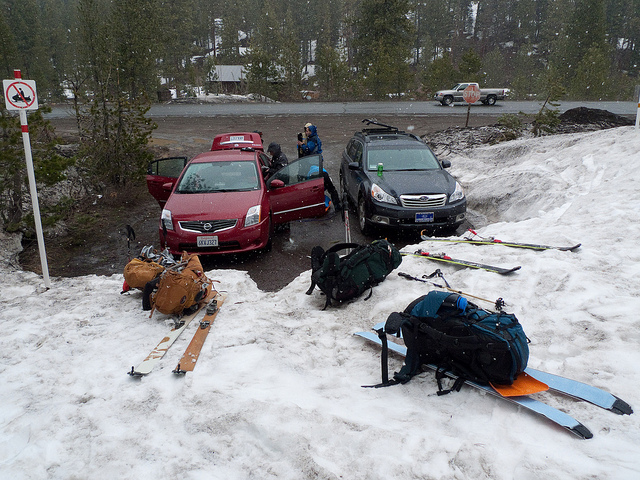<image>What make is the red car? I don't know the make of the red car. It could be Toyota, Nissan, or Honda. What make is the red car? I am not sure what make the red car is. It can be either Toyota, Nissan, Honda or something else. 